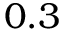<formula> <loc_0><loc_0><loc_500><loc_500>0 . 3</formula> 